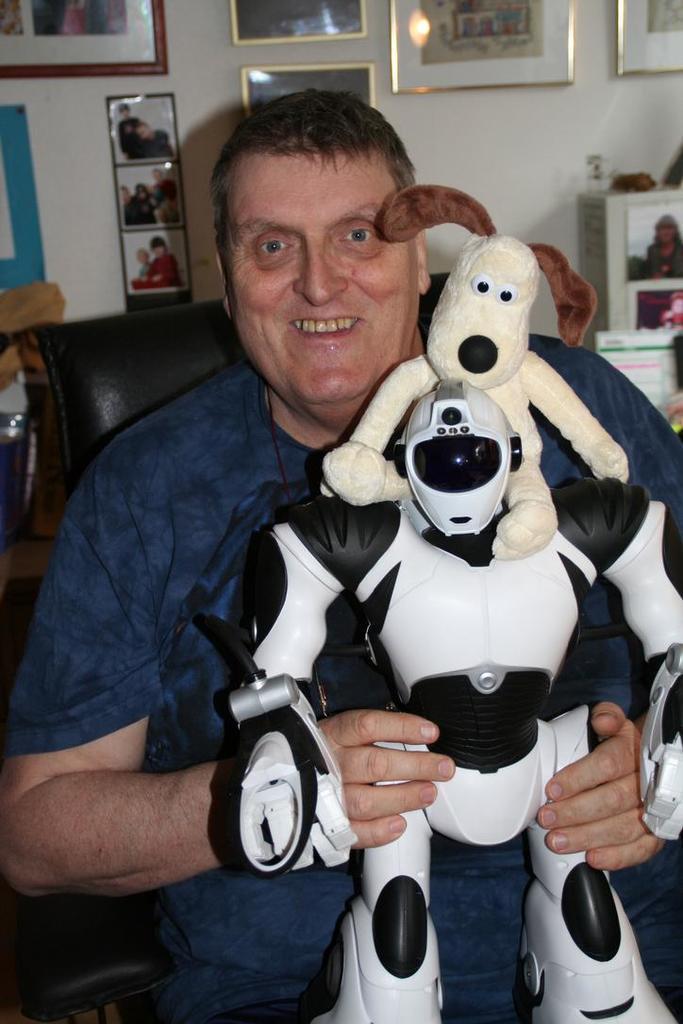Please provide a concise description of this image. In this image we can see a person sitting on a chair and holding an object. And at the back we can see photo frames attached to the wall and there are few objects on both the sides. 